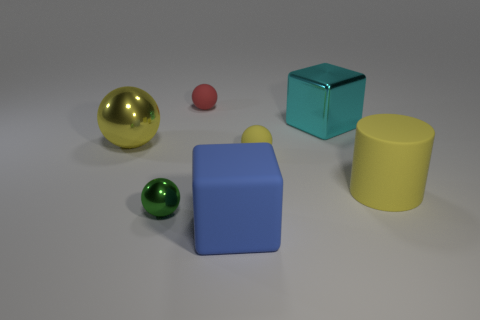How many cyan metallic things have the same size as the blue object?
Make the answer very short. 1. Is the number of blue blocks right of the big yellow cylinder greater than the number of red things that are on the left side of the yellow metallic ball?
Provide a short and direct response. No. The big object that is to the left of the metal object that is in front of the large yellow sphere is what color?
Provide a succinct answer. Yellow. Is the material of the tiny yellow ball the same as the blue cube?
Provide a short and direct response. Yes. Is there a tiny red object of the same shape as the tiny yellow thing?
Provide a succinct answer. Yes. Does the rubber ball behind the cyan shiny cube have the same color as the metal cube?
Give a very brief answer. No. Is the size of the matte sphere behind the cyan metal thing the same as the matte sphere that is to the right of the big blue rubber thing?
Give a very brief answer. Yes. What size is the cube that is the same material as the green thing?
Offer a terse response. Large. What number of spheres are both on the left side of the tiny green shiny thing and behind the yellow shiny sphere?
Provide a succinct answer. 0. What number of things are either blocks or big objects that are in front of the cyan block?
Offer a very short reply. 4. 